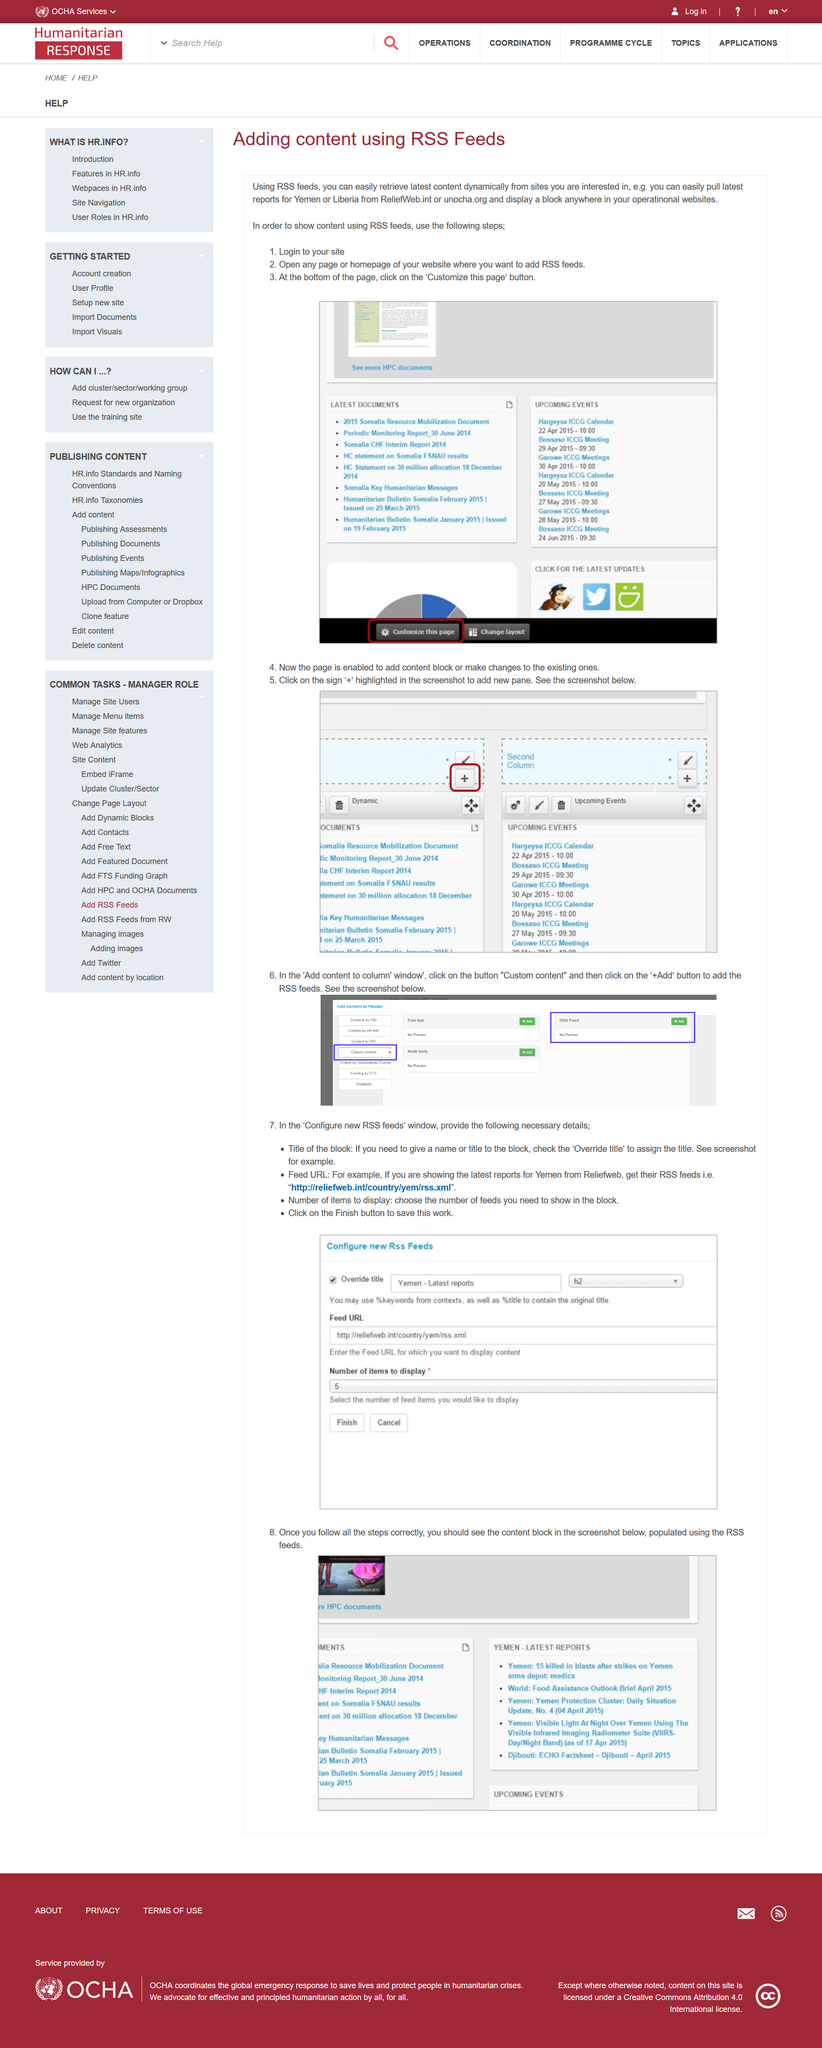Highlight a few significant elements in this photo. Three steps are listed to display content using RSS feeds. In the third step of displaying content using RSS feeds, the "Customize this page" button must be clicked. RSS feeds allow for the retrieval of dynamic data. 